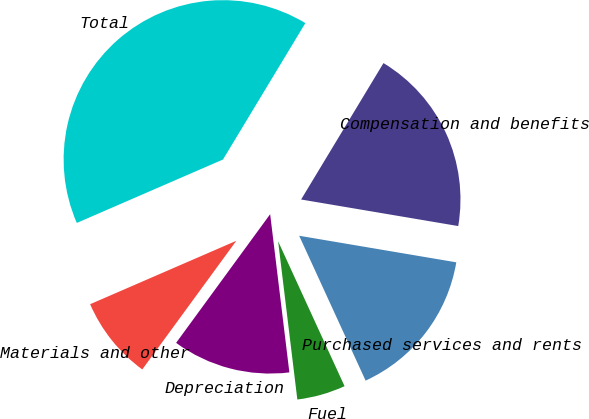Convert chart to OTSL. <chart><loc_0><loc_0><loc_500><loc_500><pie_chart><fcel>Compensation and benefits<fcel>Purchased services and rents<fcel>Fuel<fcel>Depreciation<fcel>Materials and other<fcel>Total<nl><fcel>19.02%<fcel>15.49%<fcel>4.92%<fcel>11.97%<fcel>8.44%<fcel>40.16%<nl></chart> 